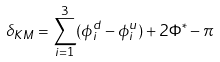Convert formula to latex. <formula><loc_0><loc_0><loc_500><loc_500>\delta _ { K M } = \sum _ { i = 1 } ^ { 3 } ( \phi _ { i } ^ { d } - \phi _ { i } ^ { u } ) + 2 \Phi ^ { * } - \pi</formula> 